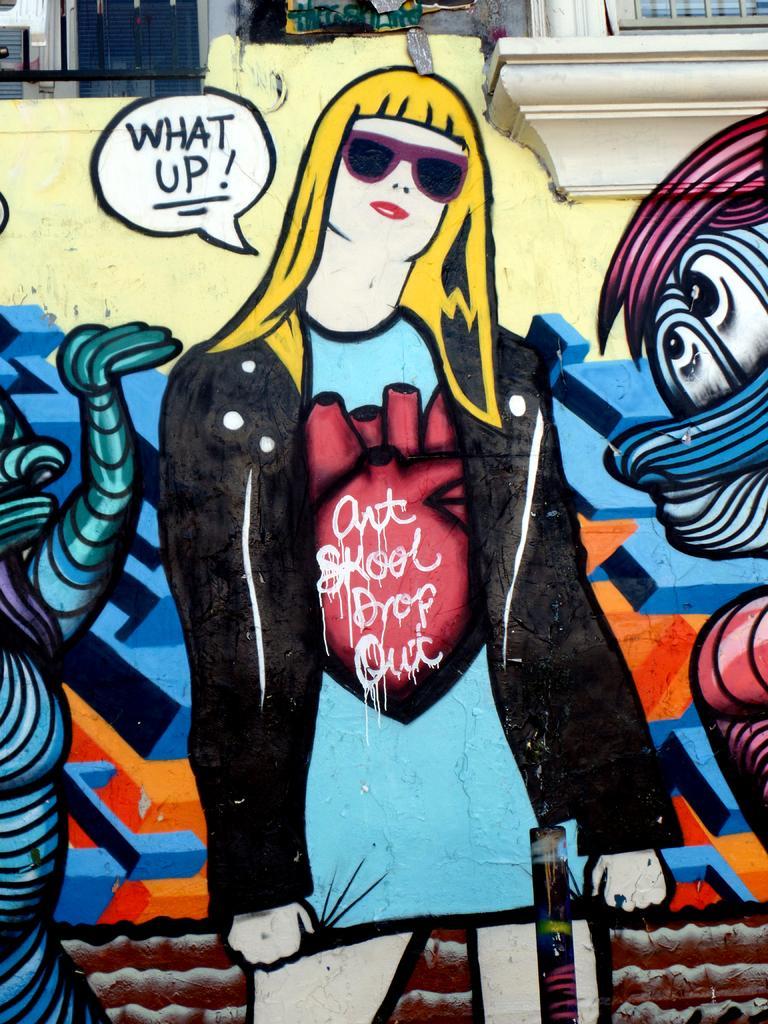Please provide a concise description of this image. In this image I can see a cartoon person wearing black and blue dress. Background I can see colorful wall and two windows. 